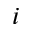<formula> <loc_0><loc_0><loc_500><loc_500>i</formula> 